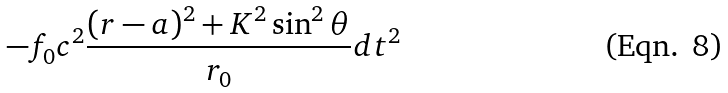Convert formula to latex. <formula><loc_0><loc_0><loc_500><loc_500>- f _ { 0 } c ^ { 2 } \frac { ( r - a ) ^ { 2 } + K ^ { 2 } \sin ^ { 2 } \theta } { r _ { 0 } } d t ^ { 2 }</formula> 